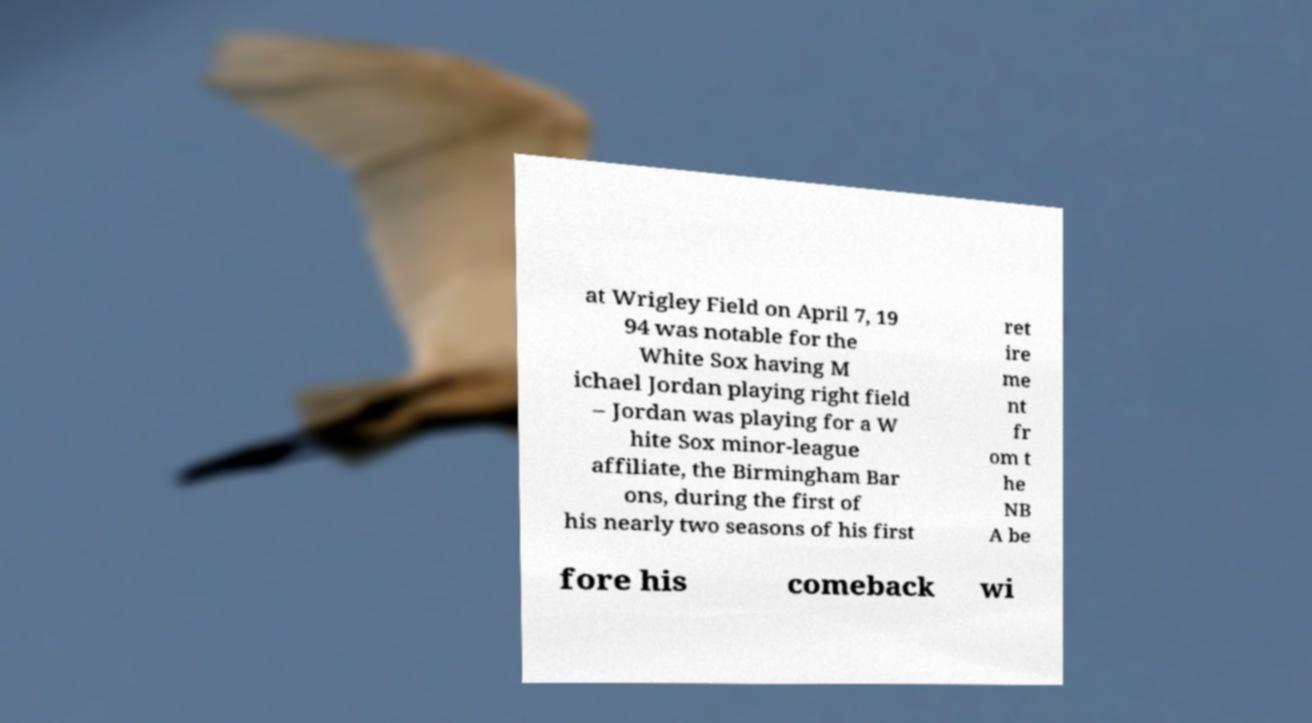Can you accurately transcribe the text from the provided image for me? at Wrigley Field on April 7, 19 94 was notable for the White Sox having M ichael Jordan playing right field – Jordan was playing for a W hite Sox minor-league affiliate, the Birmingham Bar ons, during the first of his nearly two seasons of his first ret ire me nt fr om t he NB A be fore his comeback wi 